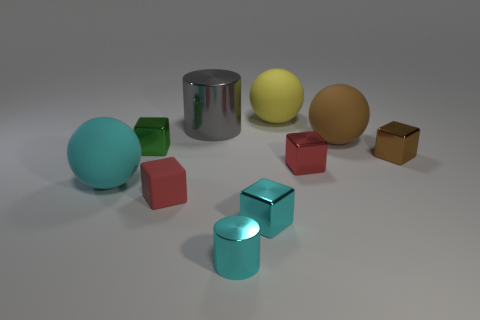Subtract all small red matte blocks. How many blocks are left? 4 Subtract all cyan spheres. How many spheres are left? 2 Subtract all spheres. How many objects are left? 7 Subtract 4 cubes. How many cubes are left? 1 Subtract all gray cylinders. How many brown blocks are left? 1 Subtract all large gray cylinders. Subtract all small green metallic cubes. How many objects are left? 8 Add 7 big cyan things. How many big cyan things are left? 8 Add 7 big brown balls. How many big brown balls exist? 8 Subtract 0 green spheres. How many objects are left? 10 Subtract all green balls. Subtract all purple cylinders. How many balls are left? 3 